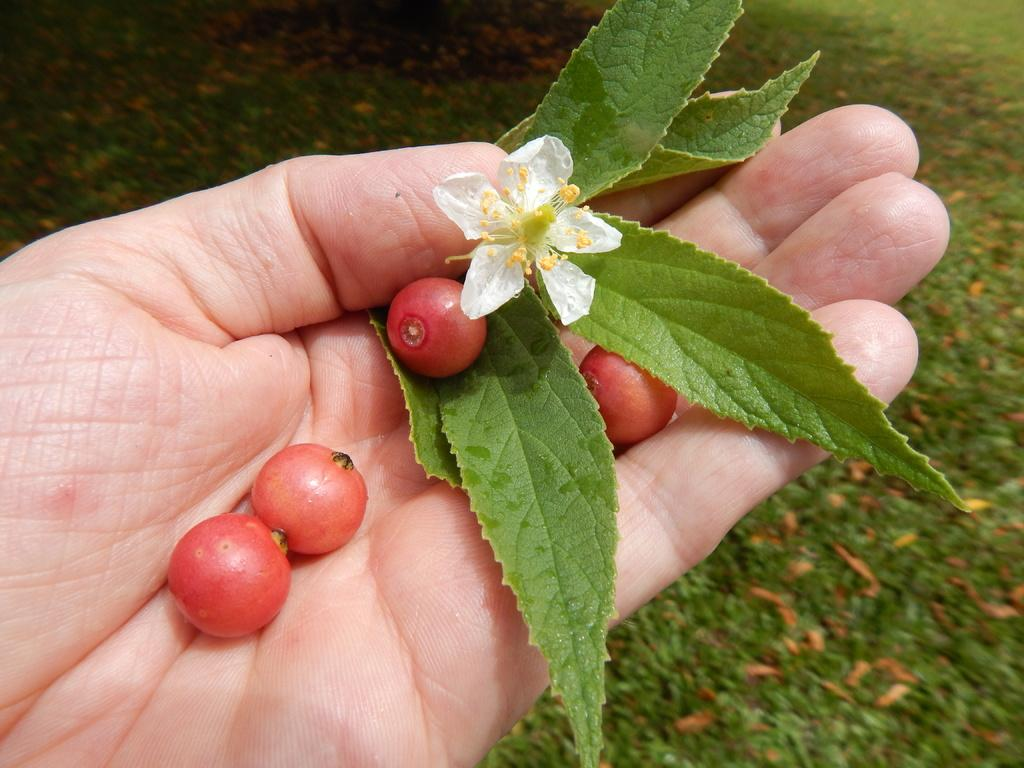What is the main subject of the image? The main subject of the image is a human hand. What is the hand holding in the image? The hand is holding leaves, a flower, and berries in the image. What type of key is the owl holding in the image? There is no owl or key present in the image; it features a human hand holding leaves, a flower, and berries. 